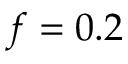Convert formula to latex. <formula><loc_0><loc_0><loc_500><loc_500>f = 0 . 2</formula> 